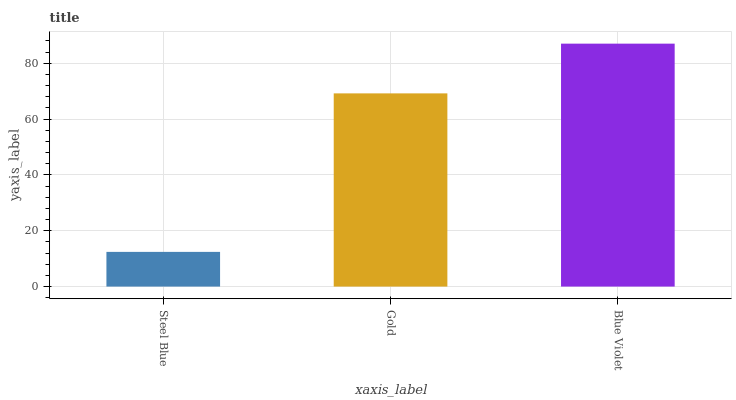Is Steel Blue the minimum?
Answer yes or no. Yes. Is Blue Violet the maximum?
Answer yes or no. Yes. Is Gold the minimum?
Answer yes or no. No. Is Gold the maximum?
Answer yes or no. No. Is Gold greater than Steel Blue?
Answer yes or no. Yes. Is Steel Blue less than Gold?
Answer yes or no. Yes. Is Steel Blue greater than Gold?
Answer yes or no. No. Is Gold less than Steel Blue?
Answer yes or no. No. Is Gold the high median?
Answer yes or no. Yes. Is Gold the low median?
Answer yes or no. Yes. Is Blue Violet the high median?
Answer yes or no. No. Is Blue Violet the low median?
Answer yes or no. No. 